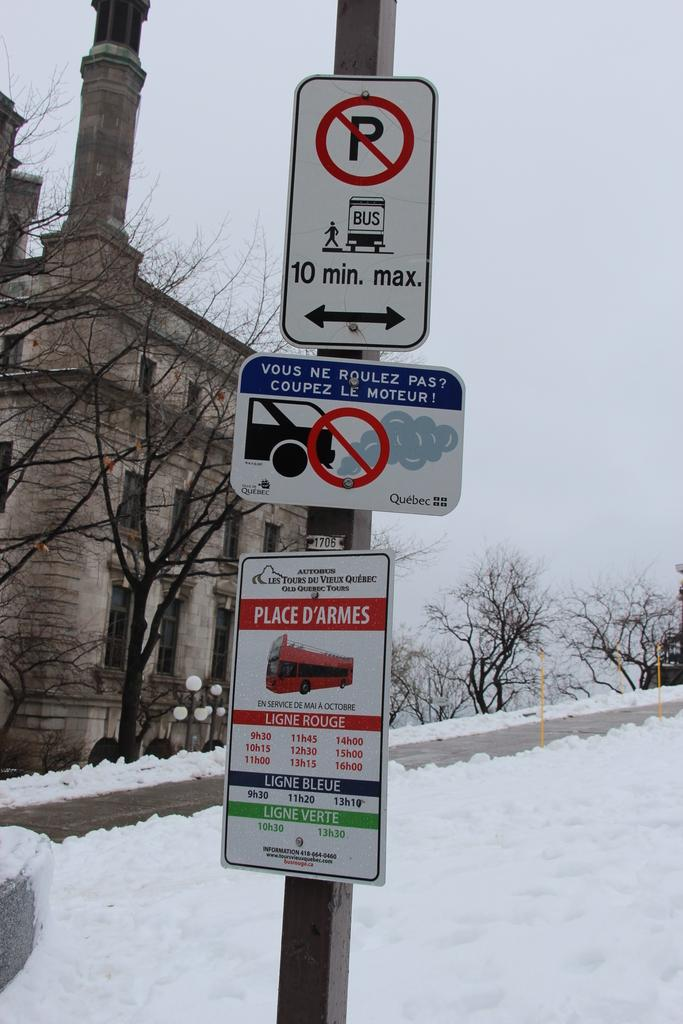<image>
Write a terse but informative summary of the picture. Three signs are on a sign pole with the top sign indicating no parking, 10 minute max. 